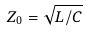<formula> <loc_0><loc_0><loc_500><loc_500>Z _ { 0 } = \sqrt { L / C }</formula> 